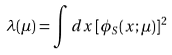<formula> <loc_0><loc_0><loc_500><loc_500>\lambda ( \mu ) = \int d x \, [ \phi _ { S } ( x ; \mu ) ] ^ { 2 }</formula> 